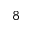Convert formula to latex. <formula><loc_0><loc_0><loc_500><loc_500>^ { 8 }</formula> 